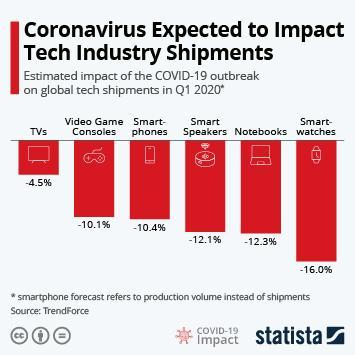Shipment of which product is impacted nearly equal as notebooks?
Answer the question with a short phrase. smart speakers Shipment of which product is more impacted by Covid-19 - TVs, smartwatches or smartphones? smartwatches How many products are given in the bar chart? 6 Shipment of which product is impacted more - smart phones or smart speakers? smart speakers Shipment of which product is less impacted by Covid-19 - TVs or video game consoles? TVs Shipment of which product is less impacted by Covid-19 - notebooks or smartphones? smartphones Shipment of which product is more impacted by Covid-19 - smart phones or smart watches? smart watches percentage decrease of Shipment of which product is below 10%? TVs shipment of which product is least impacted by COVID-19? TVs 